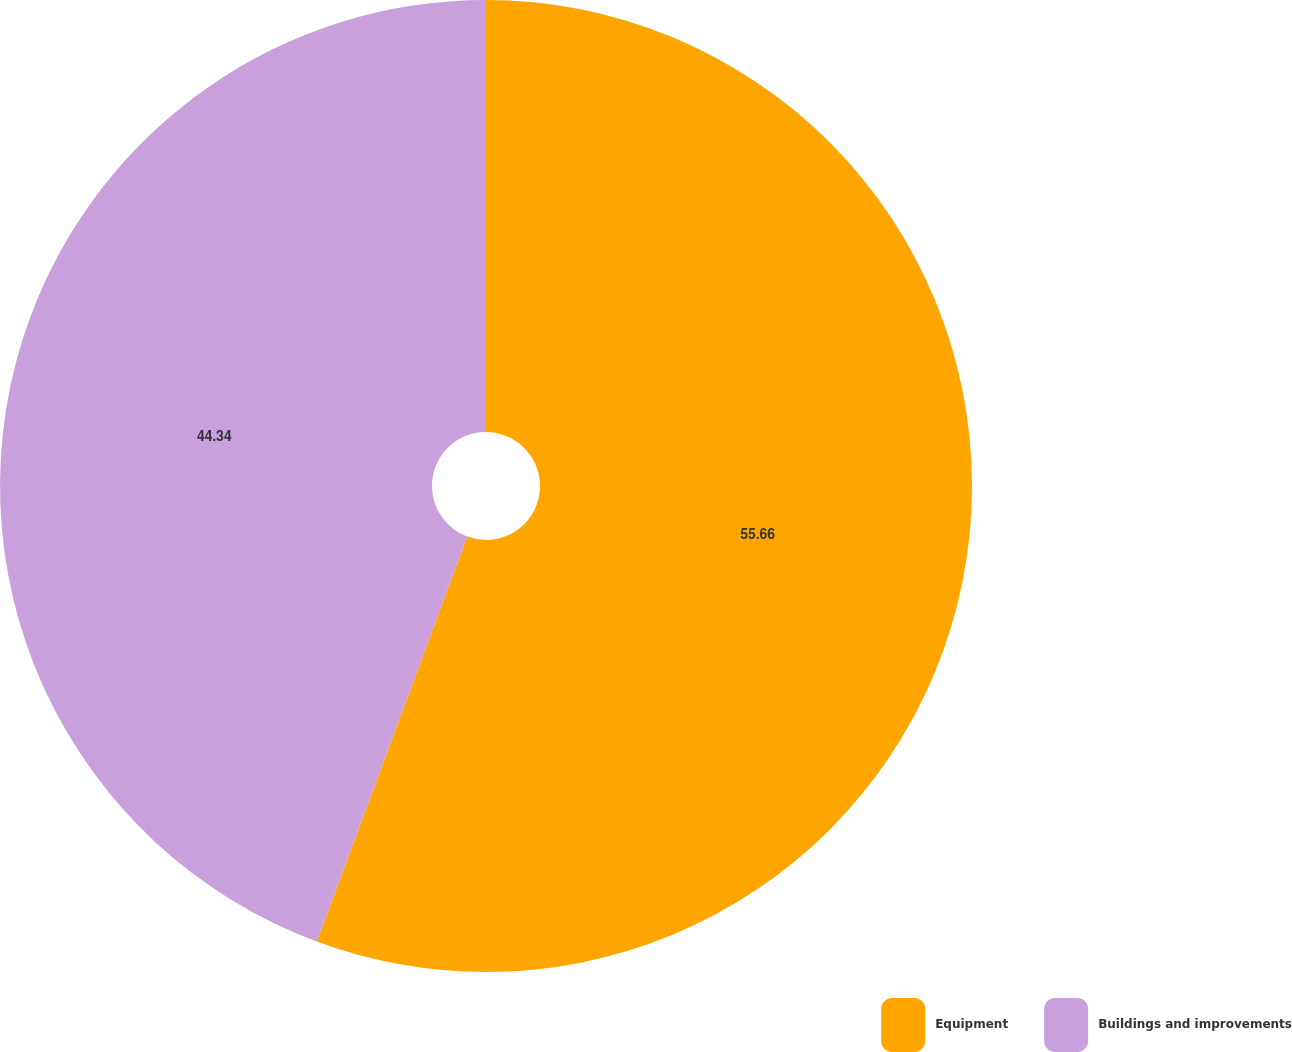Convert chart. <chart><loc_0><loc_0><loc_500><loc_500><pie_chart><fcel>Equipment<fcel>Buildings and improvements<nl><fcel>55.66%<fcel>44.34%<nl></chart> 